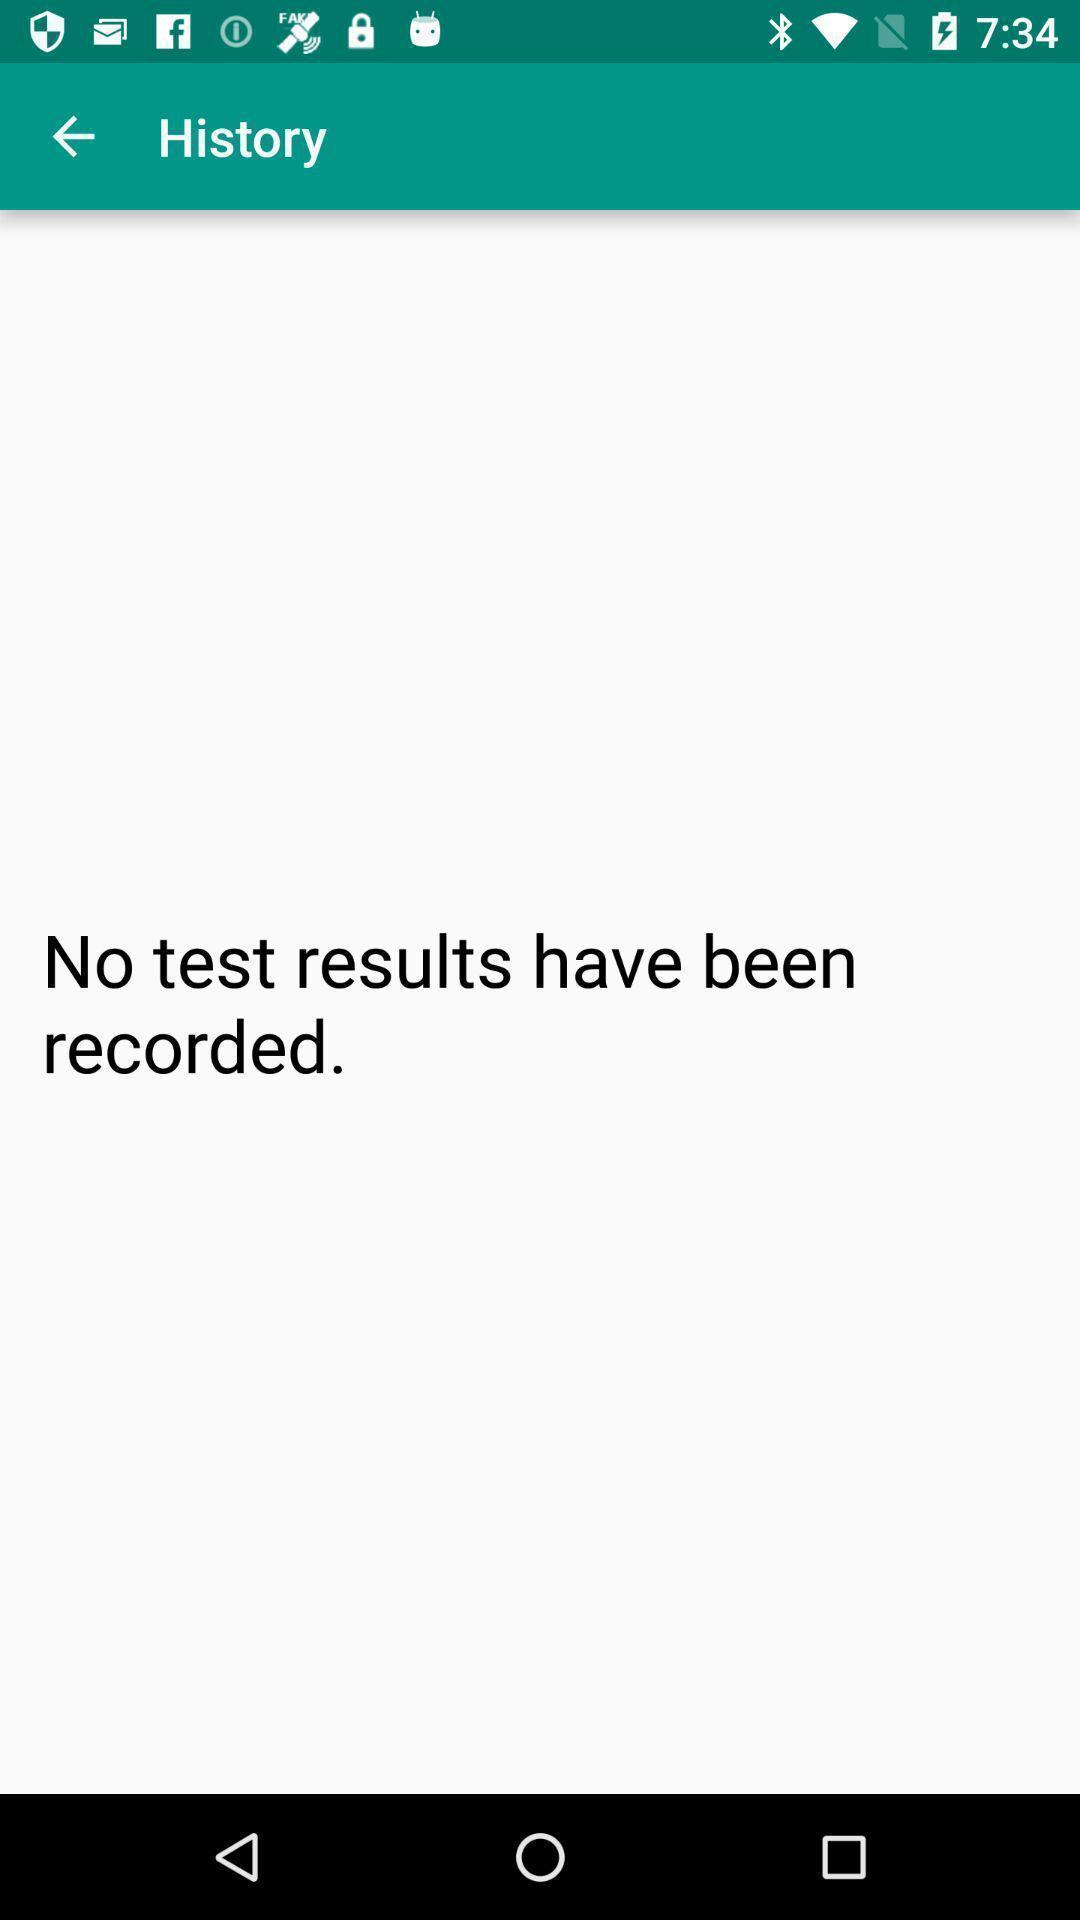Provide a textual representation of this image. Page showing information about history. 